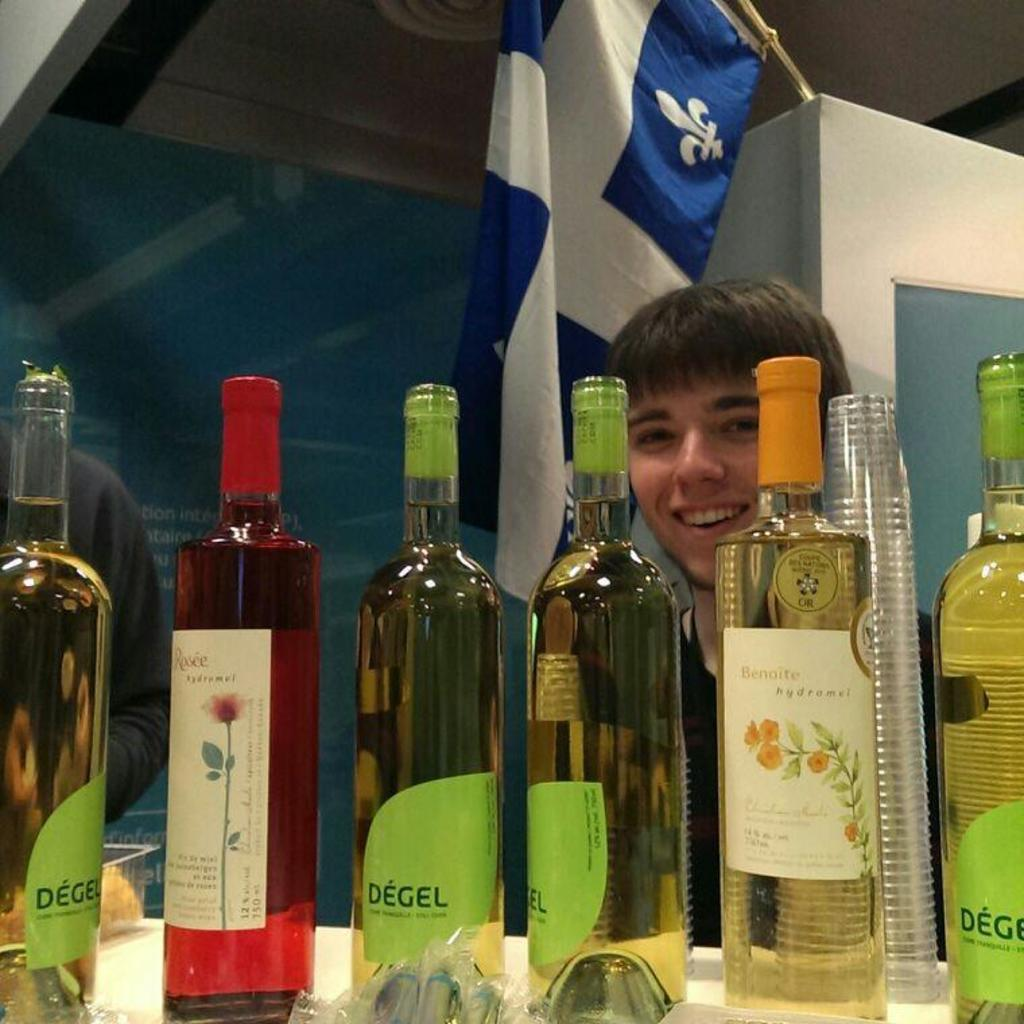<image>
Give a short and clear explanation of the subsequent image. Several bottles of Degel have green labels on them. 